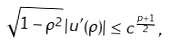Convert formula to latex. <formula><loc_0><loc_0><loc_500><loc_500>\sqrt { 1 - \rho ^ { 2 } } \, | u ^ { \prime } ( \rho ) | \leq c ^ { \frac { p + 1 } { 2 } } \, ,</formula> 